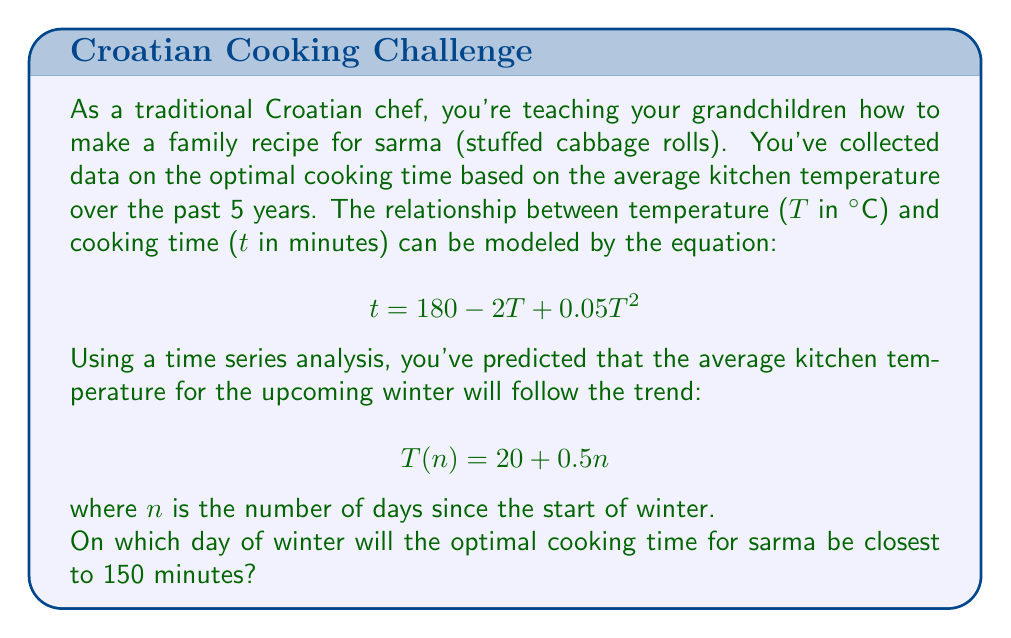Can you solve this math problem? To solve this problem, we need to follow these steps:

1) First, we need to substitute the temperature equation into the cooking time equation:

   $$ t = 180 - 2(20 + 0.5n) + 0.05(20 + 0.5n)^2 $$

2) Expand this equation:

   $$ t = 180 - 40 - n + 0.05(400 + 20n + 0.25n^2) $$
   $$ t = 140 - n + 20 + n + 0.0125n^2 $$
   $$ t = 160 + 0.0125n^2 $$

3) Now, we want to find when this is closest to 150 minutes. In other words, we want to minimize the absolute difference:

   $$ |160 + 0.0125n^2 - 150| $$

4) This is equivalent to solving:

   $$ 160 + 0.0125n^2 - 150 = 0 $$
   $$ 0.0125n^2 = -10 $$
   $$ n^2 = -800 $$

5) However, n^2 can't be negative, so there's no exact solution. The closest we can get is when n^2 = 800.

6) Solving for n:

   $$ n = \sqrt{800} \approx 28.28 $$

7) Since n must be a whole number (as it represents days), we need to check both n = 28 and n = 29.

   For n = 28: t = 160 + 0.0125(28^2) = 169.8 minutes
   For n = 29: t = 160 + 0.0125(29^2) = 170.5125 minutes

8) 169.8 is closer to 150 than 170.5125, so n = 28 is our answer.
Answer: The optimal cooking time for sarma will be closest to 150 minutes on the 28th day of winter. 